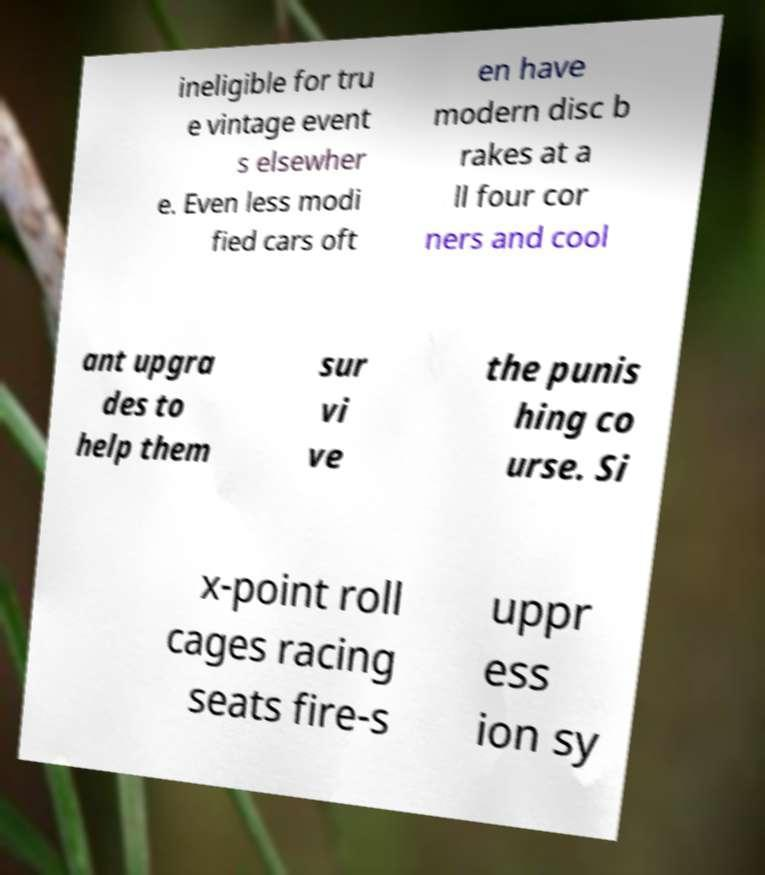For documentation purposes, I need the text within this image transcribed. Could you provide that? ineligible for tru e vintage event s elsewher e. Even less modi fied cars oft en have modern disc b rakes at a ll four cor ners and cool ant upgra des to help them sur vi ve the punis hing co urse. Si x-point roll cages racing seats fire-s uppr ess ion sy 